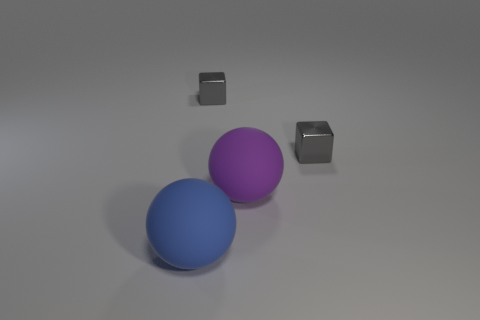Add 4 blue rubber objects. How many objects exist? 8 Add 4 big purple balls. How many big purple balls are left? 5 Add 2 blue rubber spheres. How many blue rubber spheres exist? 3 Subtract 0 green cylinders. How many objects are left? 4 Subtract all small red metallic cylinders. Subtract all tiny gray metal cubes. How many objects are left? 2 